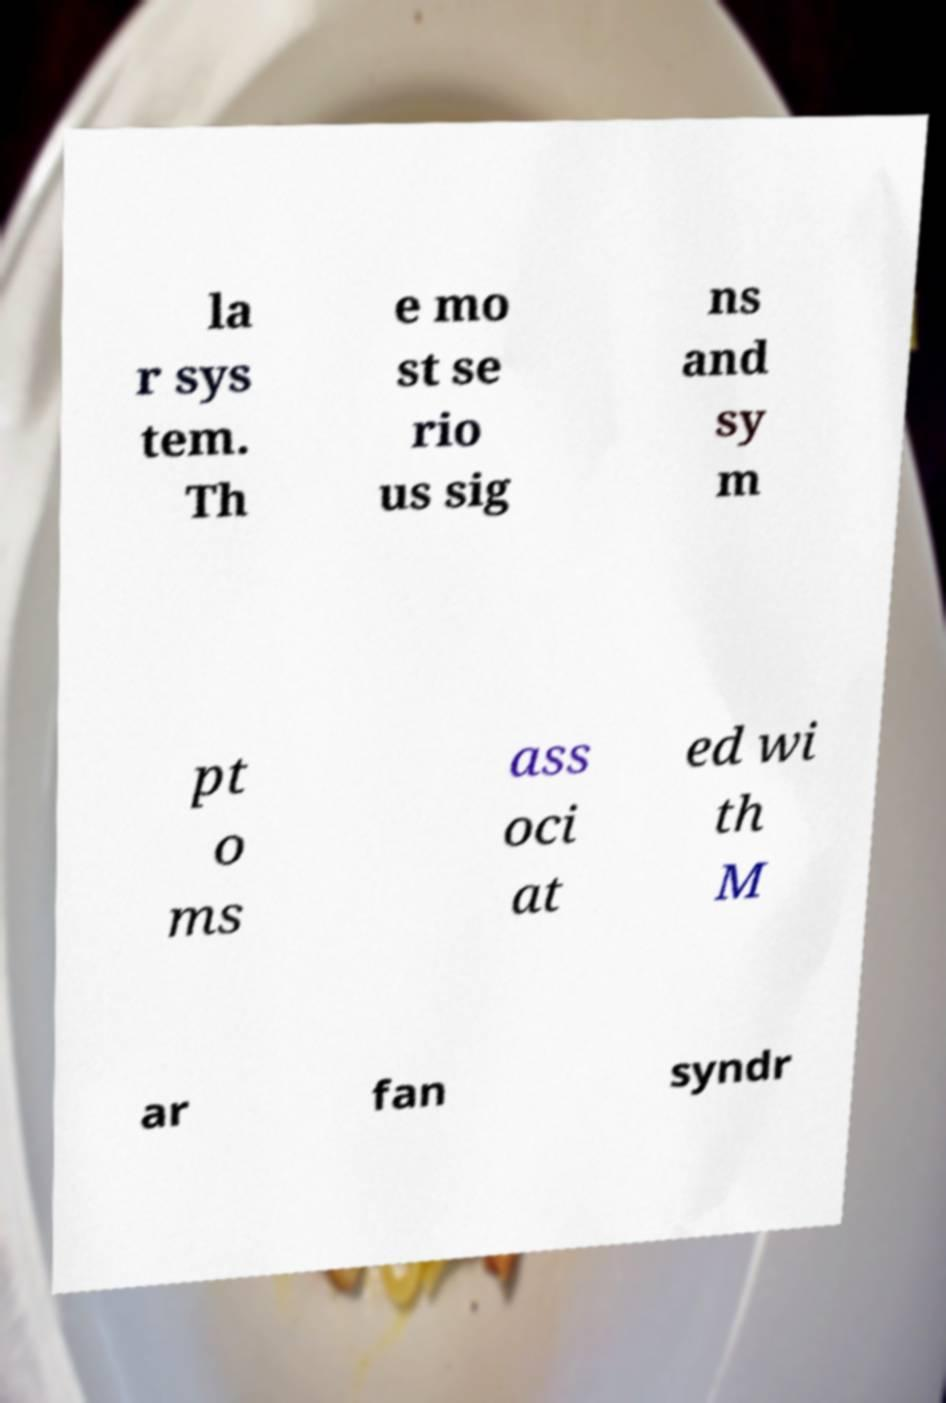For documentation purposes, I need the text within this image transcribed. Could you provide that? la r sys tem. Th e mo st se rio us sig ns and sy m pt o ms ass oci at ed wi th M ar fan syndr 